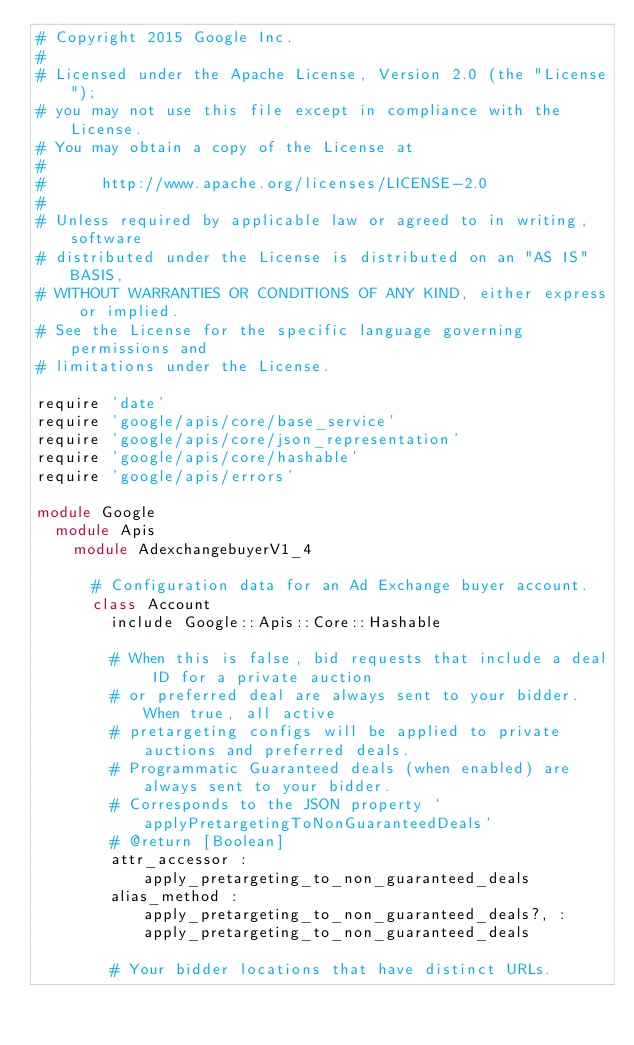Convert code to text. <code><loc_0><loc_0><loc_500><loc_500><_Ruby_># Copyright 2015 Google Inc.
#
# Licensed under the Apache License, Version 2.0 (the "License");
# you may not use this file except in compliance with the License.
# You may obtain a copy of the License at
#
#      http://www.apache.org/licenses/LICENSE-2.0
#
# Unless required by applicable law or agreed to in writing, software
# distributed under the License is distributed on an "AS IS" BASIS,
# WITHOUT WARRANTIES OR CONDITIONS OF ANY KIND, either express or implied.
# See the License for the specific language governing permissions and
# limitations under the License.

require 'date'
require 'google/apis/core/base_service'
require 'google/apis/core/json_representation'
require 'google/apis/core/hashable'
require 'google/apis/errors'

module Google
  module Apis
    module AdexchangebuyerV1_4
      
      # Configuration data for an Ad Exchange buyer account.
      class Account
        include Google::Apis::Core::Hashable
      
        # When this is false, bid requests that include a deal ID for a private auction
        # or preferred deal are always sent to your bidder. When true, all active
        # pretargeting configs will be applied to private auctions and preferred deals.
        # Programmatic Guaranteed deals (when enabled) are always sent to your bidder.
        # Corresponds to the JSON property `applyPretargetingToNonGuaranteedDeals`
        # @return [Boolean]
        attr_accessor :apply_pretargeting_to_non_guaranteed_deals
        alias_method :apply_pretargeting_to_non_guaranteed_deals?, :apply_pretargeting_to_non_guaranteed_deals
      
        # Your bidder locations that have distinct URLs.</code> 